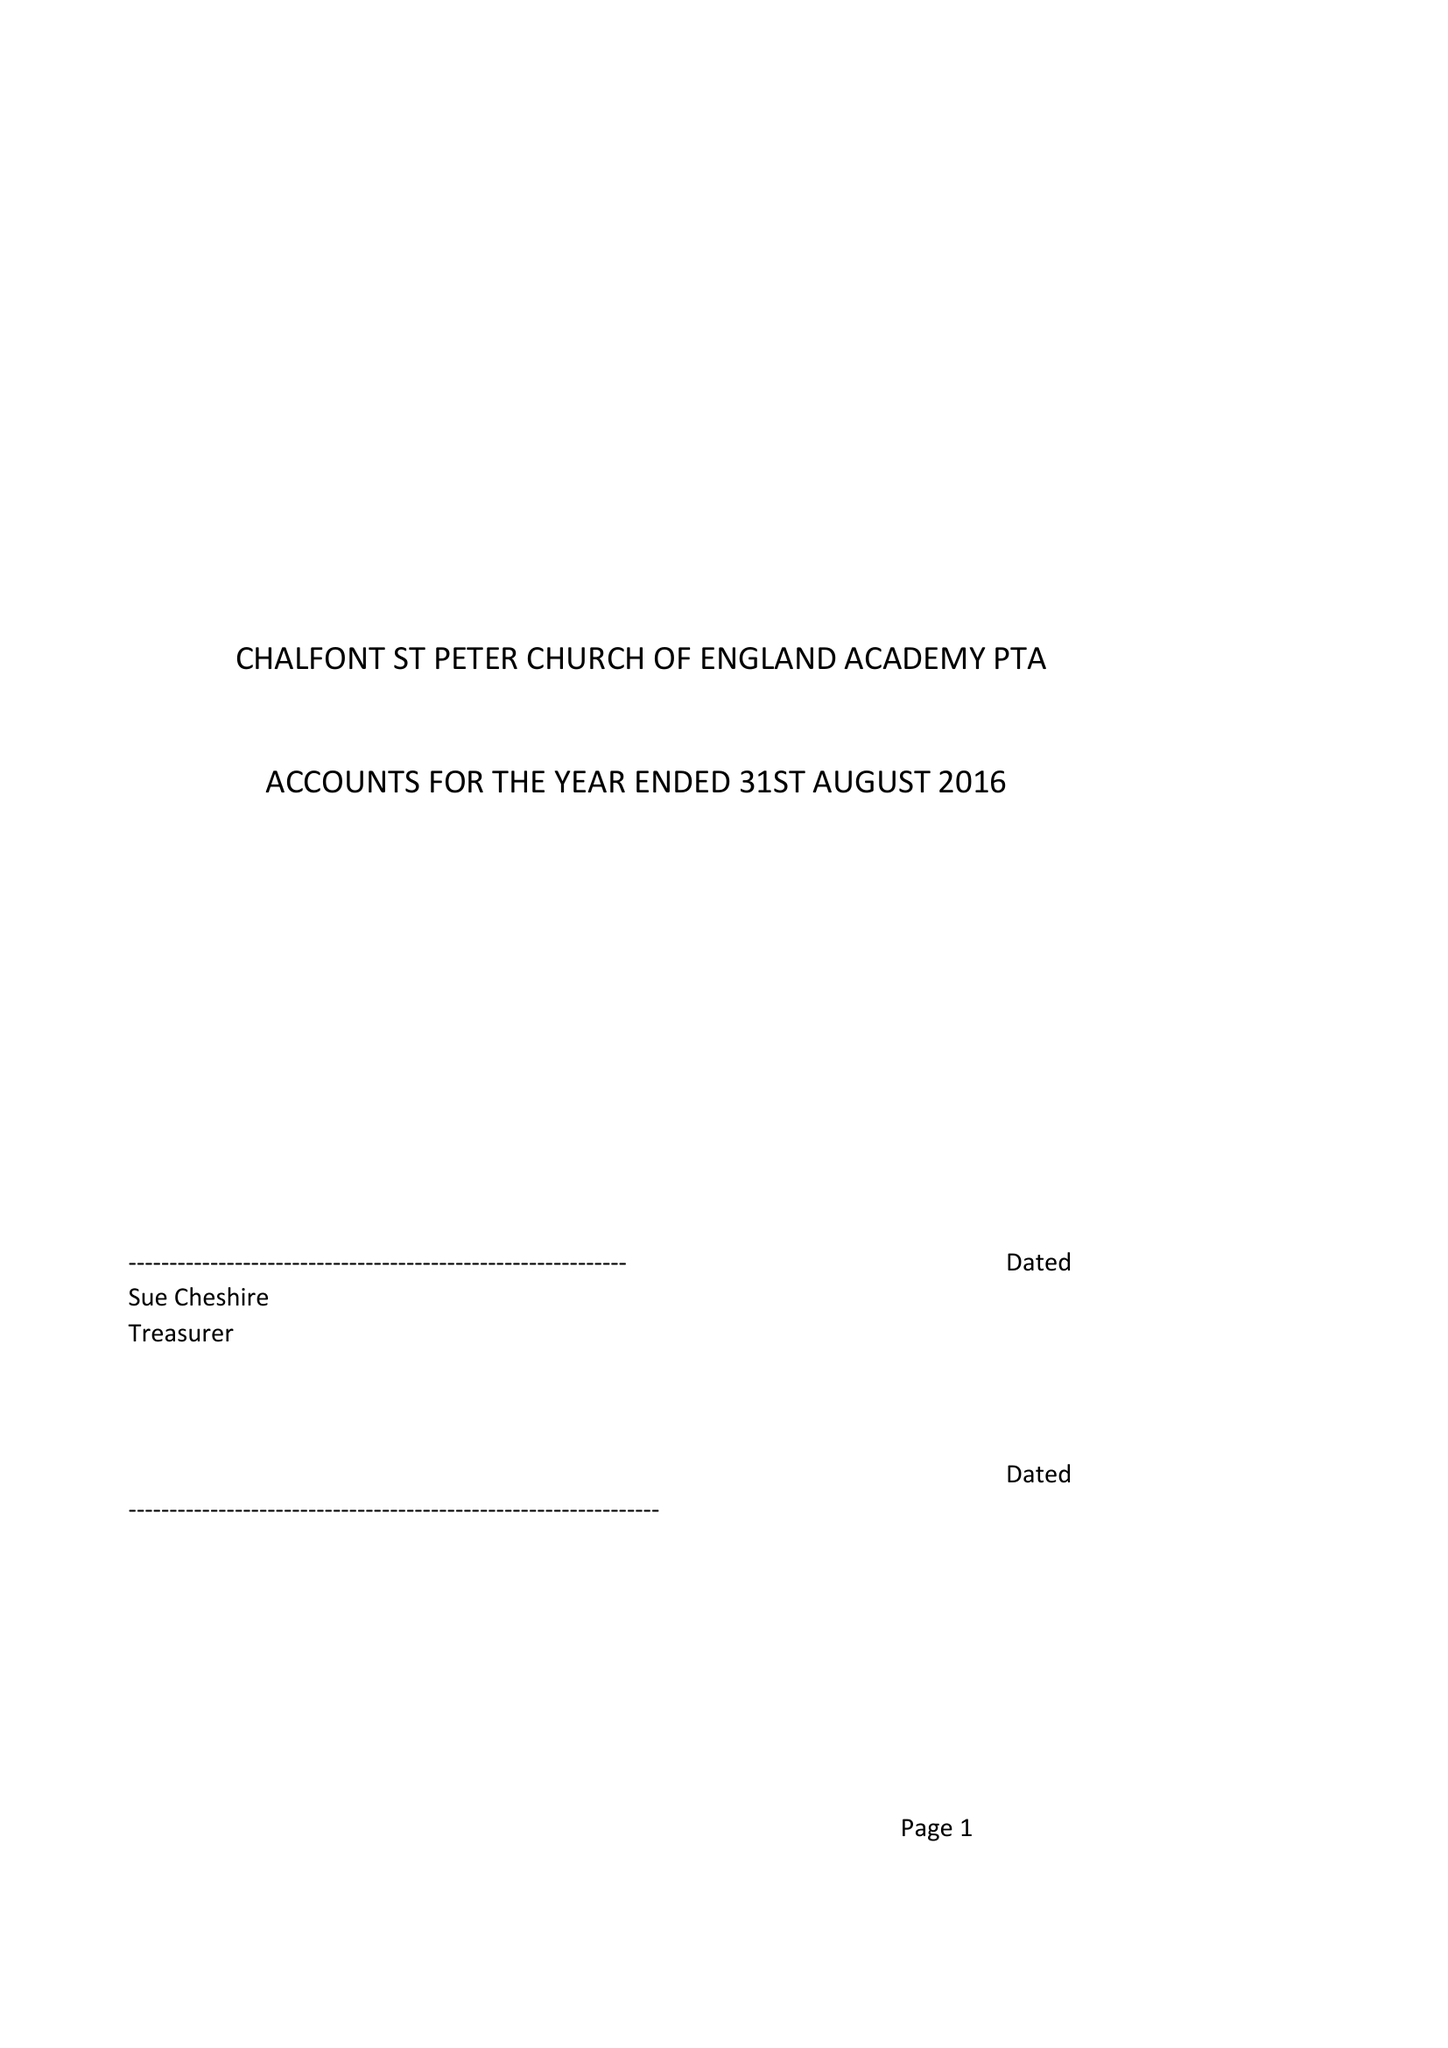What is the value for the income_annually_in_british_pounds?
Answer the question using a single word or phrase. 44475.00 